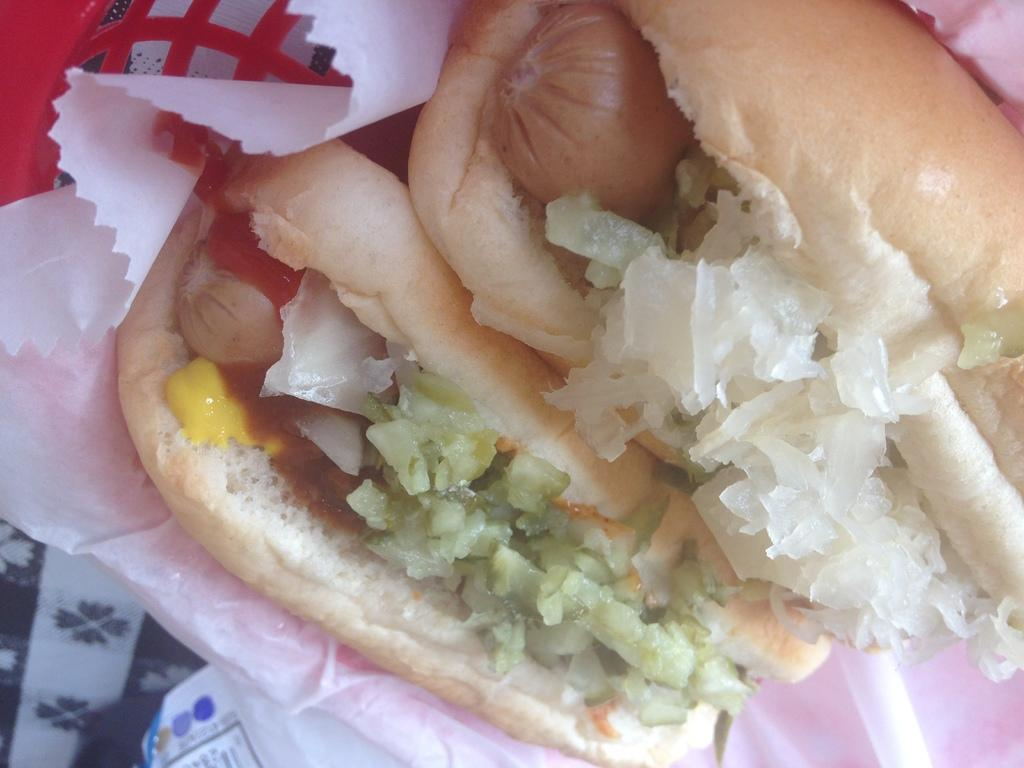What is the food item on paper in the image? The specific food item cannot be determined from the provided facts. What is the red color object in the image? The red color object in the image cannot be identified with the given information. What is the cloth in the image used for? The purpose of the cloth in the image cannot be determined from the provided facts. How many oranges are being used in the system to provide care in the image? There is no mention of oranges, a system, or care in the image. 